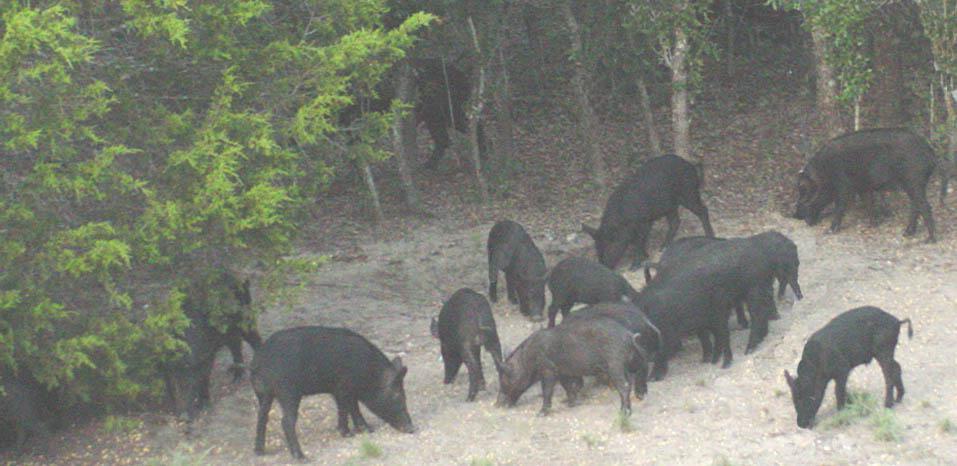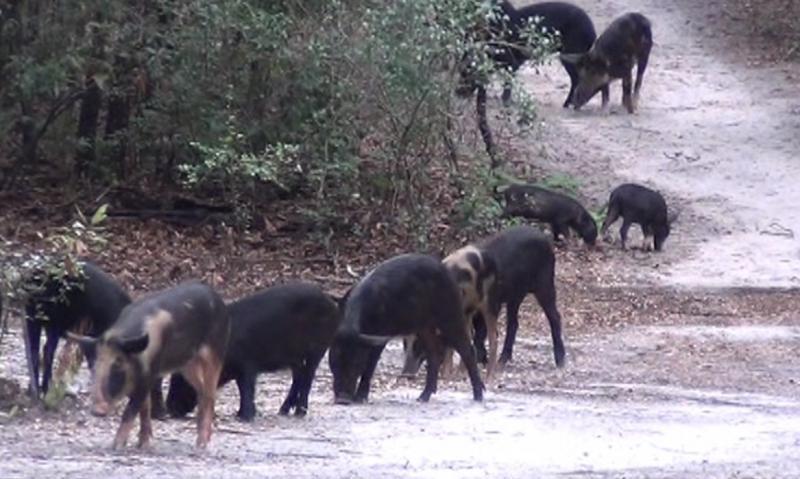The first image is the image on the left, the second image is the image on the right. For the images displayed, is the sentence "There are many wild boar hanging together in a pack near the woods" factually correct? Answer yes or no. Yes. The first image is the image on the left, the second image is the image on the right. Analyze the images presented: Is the assertion "Every picture has more than 6 pigs" valid? Answer yes or no. Yes. 